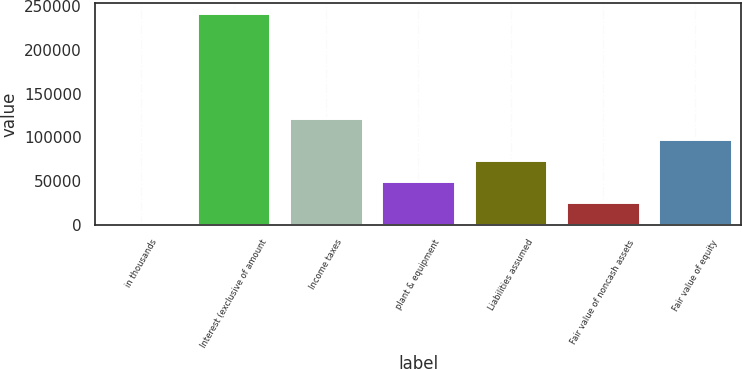Convert chart. <chart><loc_0><loc_0><loc_500><loc_500><bar_chart><fcel>in thousands<fcel>Interest (exclusive of amount<fcel>Income taxes<fcel>plant & equipment<fcel>Liabilities assumed<fcel>Fair value of noncash assets<fcel>Fair value of equity<nl><fcel>2014<fcel>241841<fcel>121928<fcel>49979.4<fcel>73962.1<fcel>25996.7<fcel>97944.8<nl></chart> 